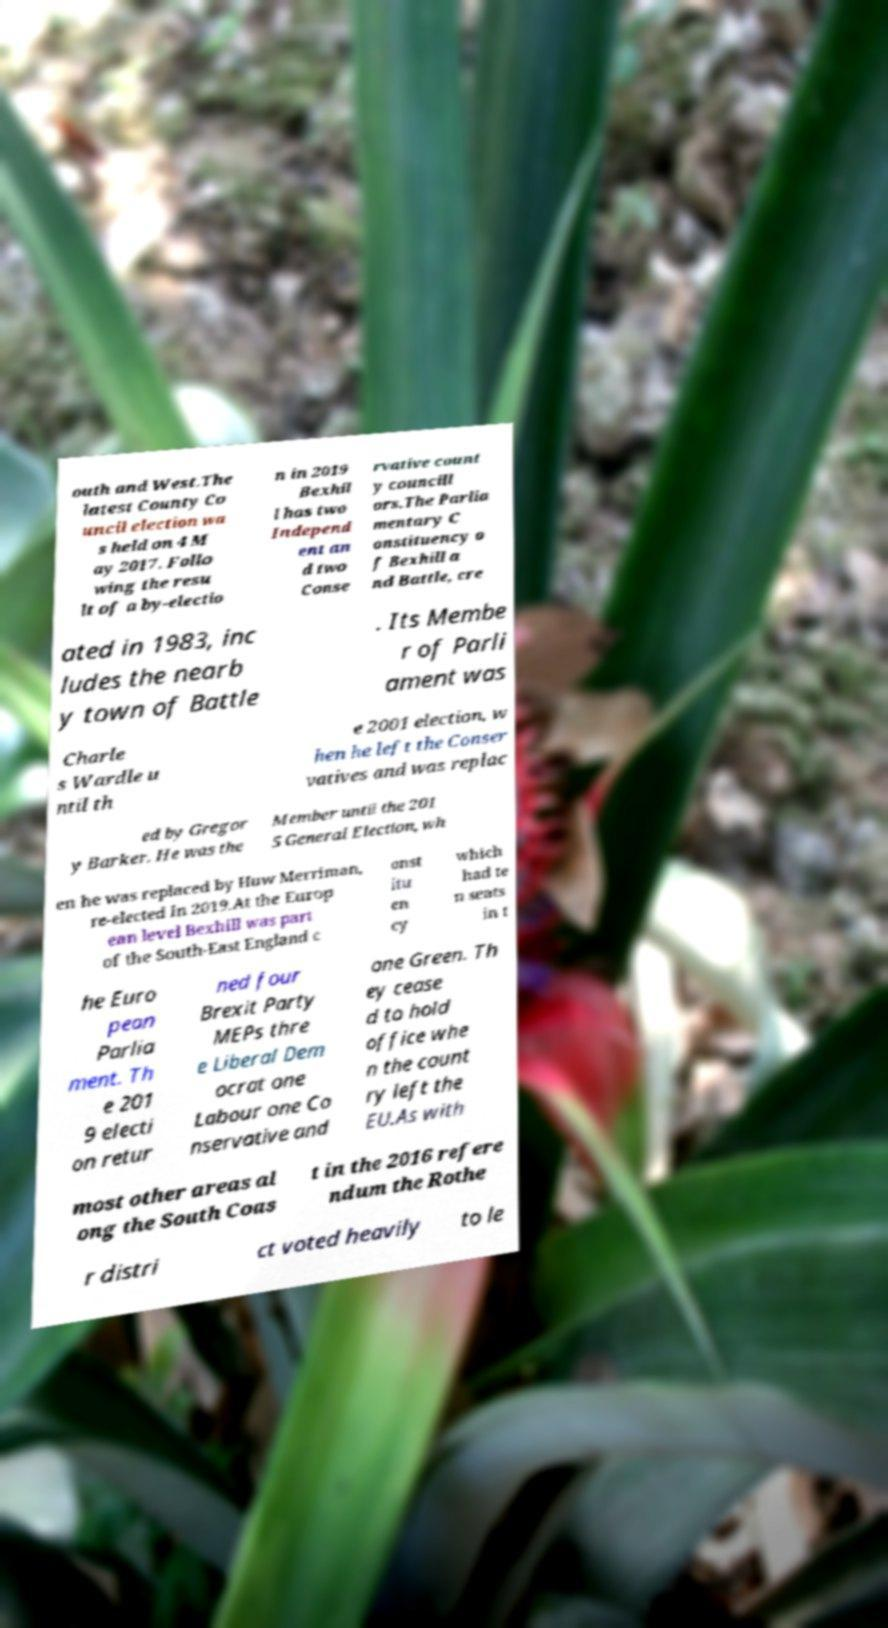Please read and relay the text visible in this image. What does it say? outh and West.The latest County Co uncil election wa s held on 4 M ay 2017. Follo wing the resu lt of a by-electio n in 2019 Bexhil l has two Independ ent an d two Conse rvative count y councill ors.The Parlia mentary C onstituency o f Bexhill a nd Battle, cre ated in 1983, inc ludes the nearb y town of Battle . Its Membe r of Parli ament was Charle s Wardle u ntil th e 2001 election, w hen he left the Conser vatives and was replac ed by Gregor y Barker. He was the Member until the 201 5 General Election, wh en he was replaced by Huw Merriman, re-elected in 2019.At the Europ ean level Bexhill was part of the South-East England c onst itu en cy which had te n seats in t he Euro pean Parlia ment. Th e 201 9 electi on retur ned four Brexit Party MEPs thre e Liberal Dem ocrat one Labour one Co nservative and one Green. Th ey cease d to hold office whe n the count ry left the EU.As with most other areas al ong the South Coas t in the 2016 refere ndum the Rothe r distri ct voted heavily to le 